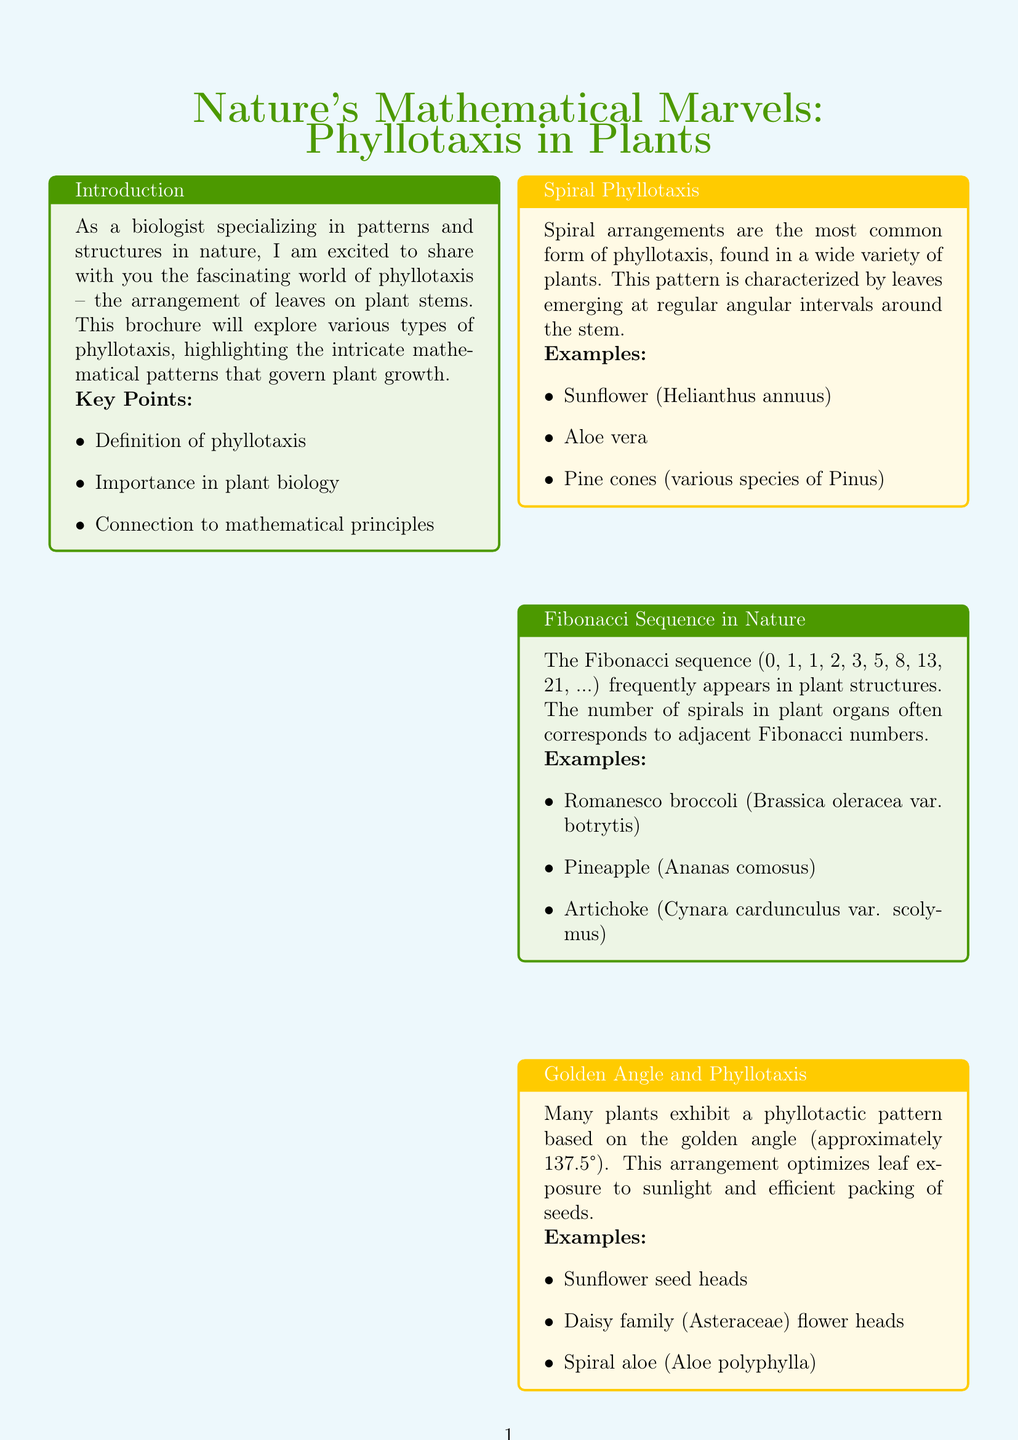What is the title of the brochure? The title of the brochure is stated at the beginning of the document.
Answer: Nature's Mathematical Marvels: Phyllotaxis in Plants Who is the author of the brochure? The author is introduced in the "About the Author" section.
Answer: Dr. Emily Greenwood What is the focus of Dr. Emily Greenwood's research? The research focus is mentioned in the author's details at the end of the brochure.
Answer: Patterns and structures in plant morphology What type of phyllotaxis involves leaves emerging at regular intervals? This information is found in the "Spiral Phyllotaxis" section.
Answer: Spiral Phyllotaxis Which plant shows the Fibonacci sequence pattern? The document lists examples of plants that exhibit the Fibonacci sequence.
Answer: Romanesco broccoli What is the angle related to the golden angle in phyllotaxis? This detail is provided under the "Golden Angle and Phyllotaxis" section.
Answer: Approximately 137.5° Which plant is an example of distichous phyllotaxis? The "Distichous Phyllotaxis" section mentions plants exhibiting this pattern.
Answer: Corn What type of phyllotaxis has multiple leaves from one node? This characteristic is described in the "Whorled Phyllotaxis" section.
Answer: Whorled Phyllotaxis What is one implication of studying phyllotaxis? The implications are listed in the conclusion section of the brochure.
Answer: Biomimicry in engineering and design 